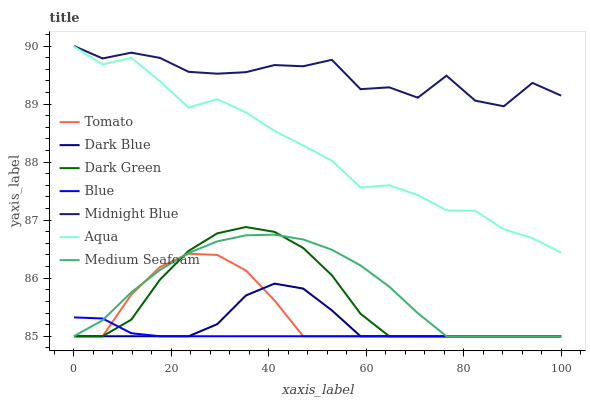Does Blue have the minimum area under the curve?
Answer yes or no. Yes. Does Midnight Blue have the maximum area under the curve?
Answer yes or no. Yes. Does Midnight Blue have the minimum area under the curve?
Answer yes or no. No. Does Blue have the maximum area under the curve?
Answer yes or no. No. Is Blue the smoothest?
Answer yes or no. Yes. Is Midnight Blue the roughest?
Answer yes or no. Yes. Is Midnight Blue the smoothest?
Answer yes or no. No. Is Blue the roughest?
Answer yes or no. No. Does Tomato have the lowest value?
Answer yes or no. Yes. Does Midnight Blue have the lowest value?
Answer yes or no. No. Does Midnight Blue have the highest value?
Answer yes or no. Yes. Does Blue have the highest value?
Answer yes or no. No. Is Tomato less than Midnight Blue?
Answer yes or no. Yes. Is Midnight Blue greater than Dark Green?
Answer yes or no. Yes. Does Tomato intersect Medium Seafoam?
Answer yes or no. Yes. Is Tomato less than Medium Seafoam?
Answer yes or no. No. Is Tomato greater than Medium Seafoam?
Answer yes or no. No. Does Tomato intersect Midnight Blue?
Answer yes or no. No. 